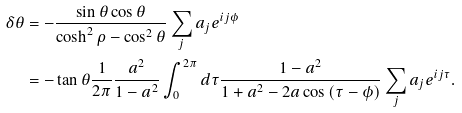<formula> <loc_0><loc_0><loc_500><loc_500>\delta \theta & = - \frac { \sin \theta \cos \theta } { \cosh ^ { 2 } \rho - \cos ^ { 2 } \theta } \sum _ { j } a _ { j } e ^ { i j \phi } \\ & = - \tan \theta \frac { 1 } { 2 \pi } \frac { a ^ { 2 } } { 1 - a ^ { 2 } } \int _ { 0 } ^ { 2 \pi } d \tau \frac { 1 - a ^ { 2 } } { 1 + a ^ { 2 } - 2 a \cos \left ( \tau - \phi \right ) } \sum _ { j } a _ { j } e ^ { i j \tau } .</formula> 